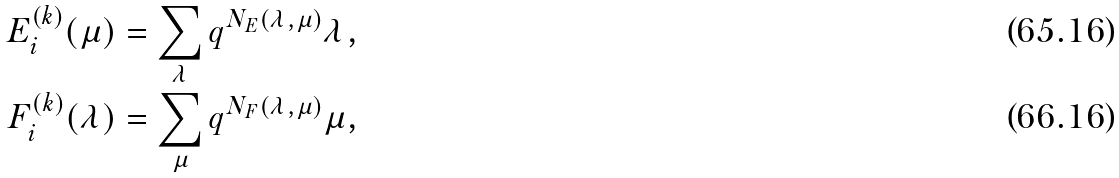<formula> <loc_0><loc_0><loc_500><loc_500>E _ { i } ^ { ( k ) } ( \mu ) & = \sum _ { \lambda } q ^ { N _ { E } ( \lambda , \mu ) } \lambda , \\ F _ { i } ^ { ( k ) } ( \lambda ) & = \sum _ { \mu } q ^ { N _ { F } ( \lambda , \mu ) } \mu ,</formula> 